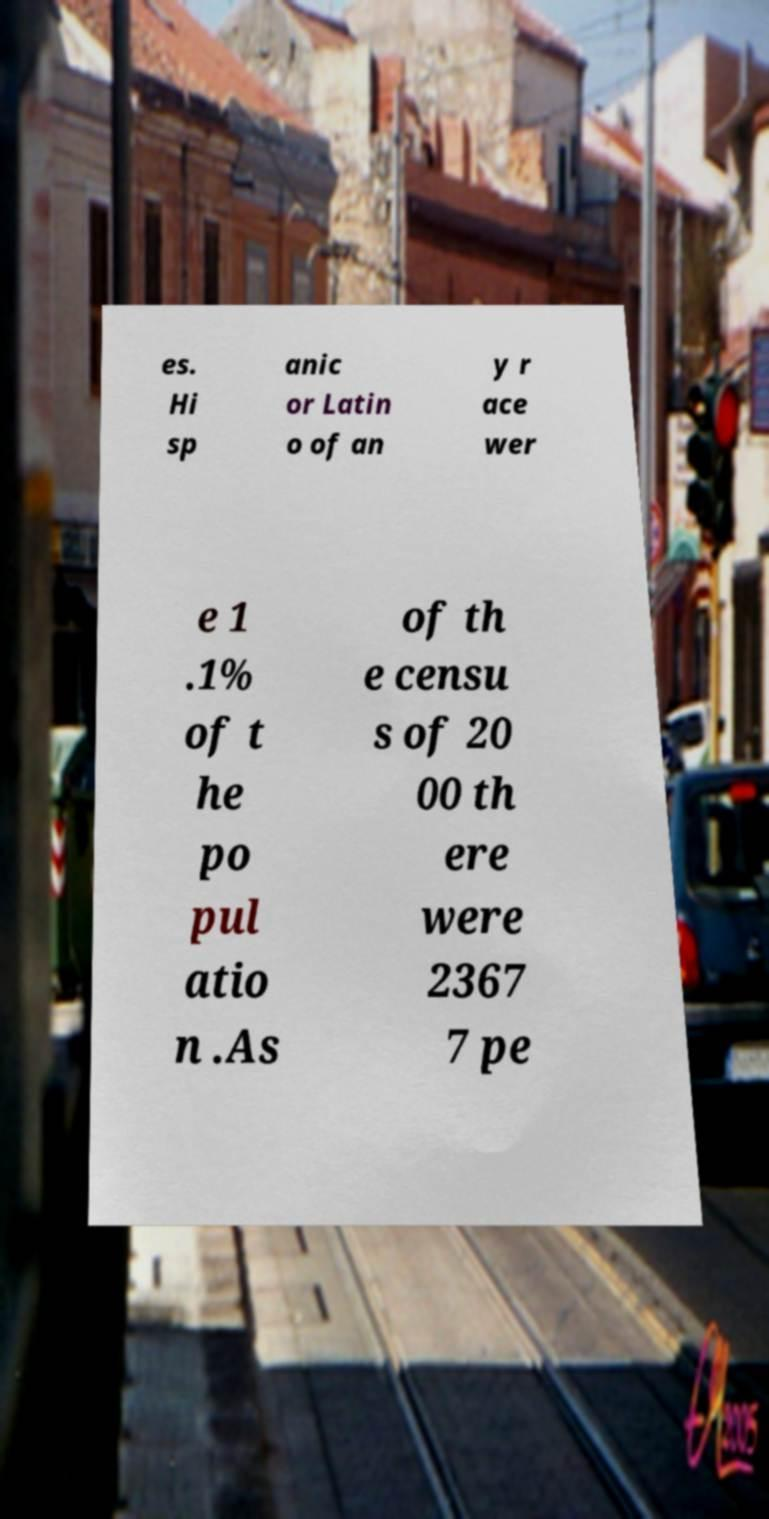For documentation purposes, I need the text within this image transcribed. Could you provide that? es. Hi sp anic or Latin o of an y r ace wer e 1 .1% of t he po pul atio n .As of th e censu s of 20 00 th ere were 2367 7 pe 